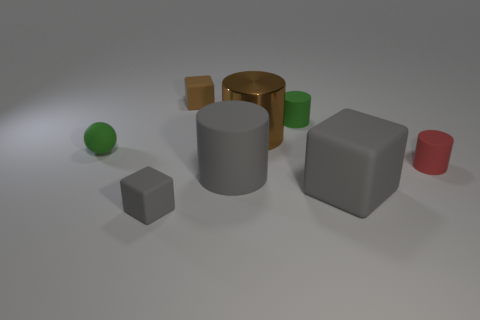Subtract all small green cylinders. How many cylinders are left? 3 Add 1 tiny cyan metal cylinders. How many objects exist? 9 Subtract all purple cylinders. Subtract all green balls. How many cylinders are left? 4 Subtract all blocks. How many objects are left? 5 Subtract 0 yellow cylinders. How many objects are left? 8 Subtract all large gray rubber cylinders. Subtract all gray objects. How many objects are left? 4 Add 3 tiny green matte cylinders. How many tiny green matte cylinders are left? 4 Add 3 small balls. How many small balls exist? 4 